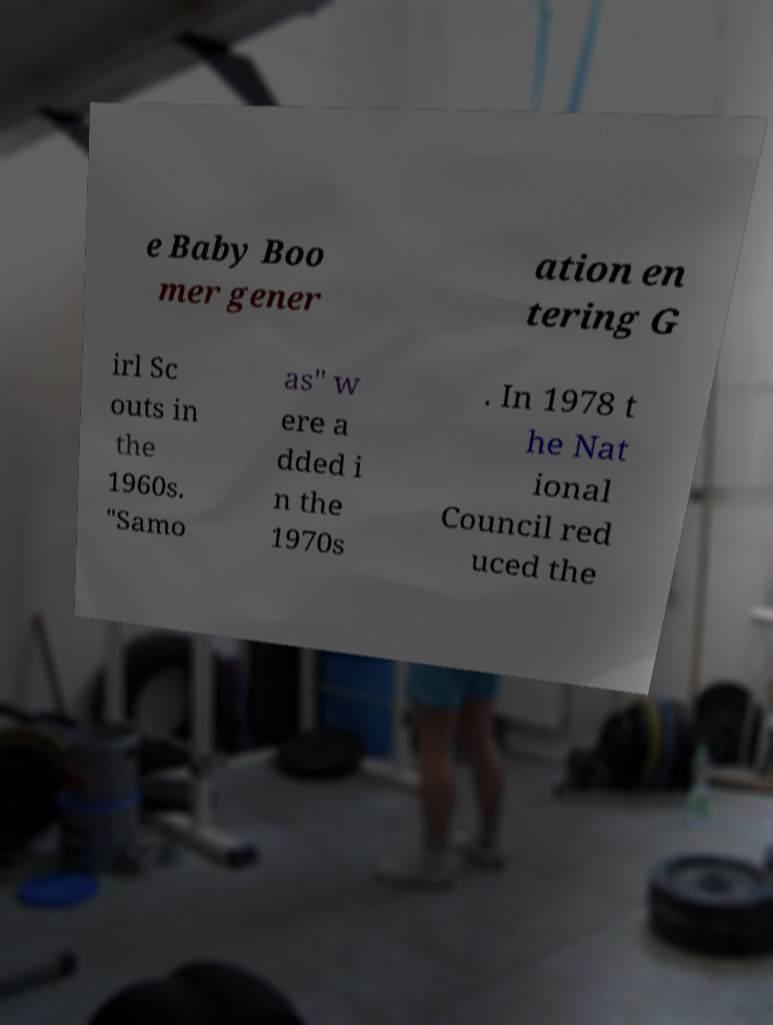Please identify and transcribe the text found in this image. e Baby Boo mer gener ation en tering G irl Sc outs in the 1960s. "Samo as" w ere a dded i n the 1970s . In 1978 t he Nat ional Council red uced the 